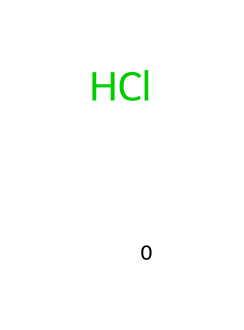What is the molecular formula of hydrochloric acid? The SMILES representation [H]Cl indicates that hydrochloric acid is composed of one hydrogen atom and one chlorine atom. Therefore, the molecular formula is simply the combination of these two elements, which defines the compound.
Answer: HCl How many atoms are present in hydrochloric acid? From the SMILES representation [H]Cl, we can count the number of atoms: 1 hydrogen atom and 1 chlorine atom. This means a total of 2 atoms are present in hydrochloric acid.
Answer: 2 What type of bond is present in hydrochloric acid? The chemical structure [H]Cl indicates that the bond between hydrogen (H) and chlorine (Cl) is a single covalent bond, as there is only one line connecting the two elements.
Answer: single covalent bond What is the pH range that hydrochloric acid typically falls under? Hydrochloric acid is classified as a strong acid, meaning it completely ionizes in water, producing a very low pH. Generally, solutions of hydrochloric acid will have a pH less than 1, depending on concentration.
Answer: less than 1 Is hydrochloric acid a strong or weak acid? Based on its properties, hydrochloric acid completely dissociates in aqueous solution, making it a strong acid. This characteristic is directly linked to its structure, which indicates a complete release of protons in solution.
Answer: strong acid What is the role of hydrochloric acid in special effects for corrosive scenes? Hydrochloric acid is used to simulate corrosive effects because of its strong acidic nature that can visually represent damage on various materials, akin to natural corrosion processes. This effect is enhanced due to its high reactivity and corrosive properties.
Answer: simulate corrosion 